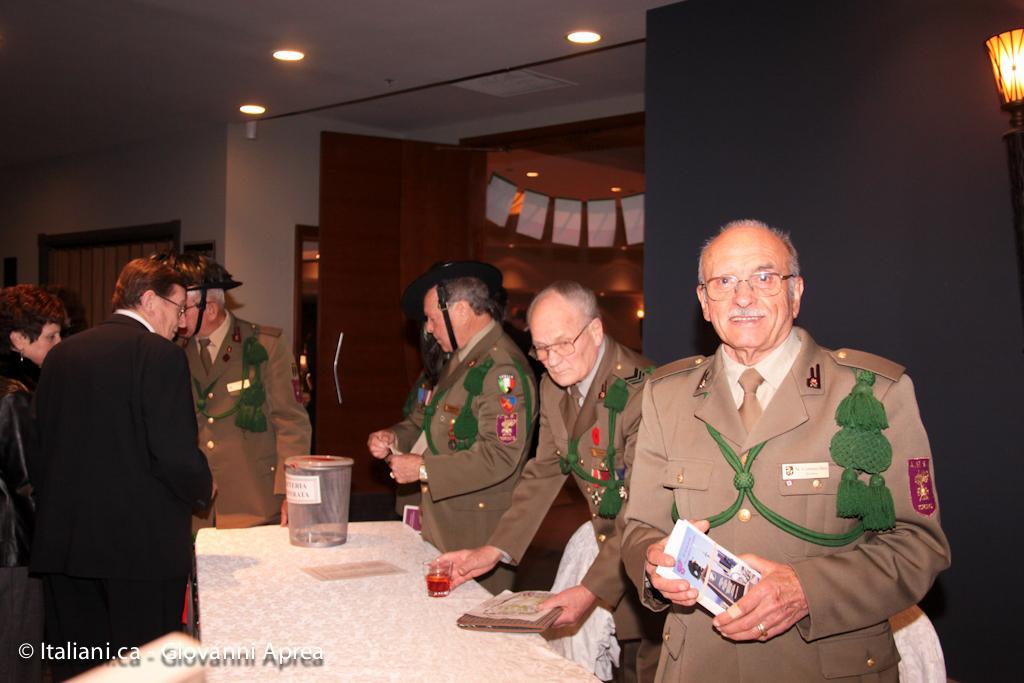Please provide a concise description of this image. In this image I can see group of people standing, the person at right wearing brown color uniform holding few papers. I can also see a glass on the table, background I can see a wooden wall and few lights. 